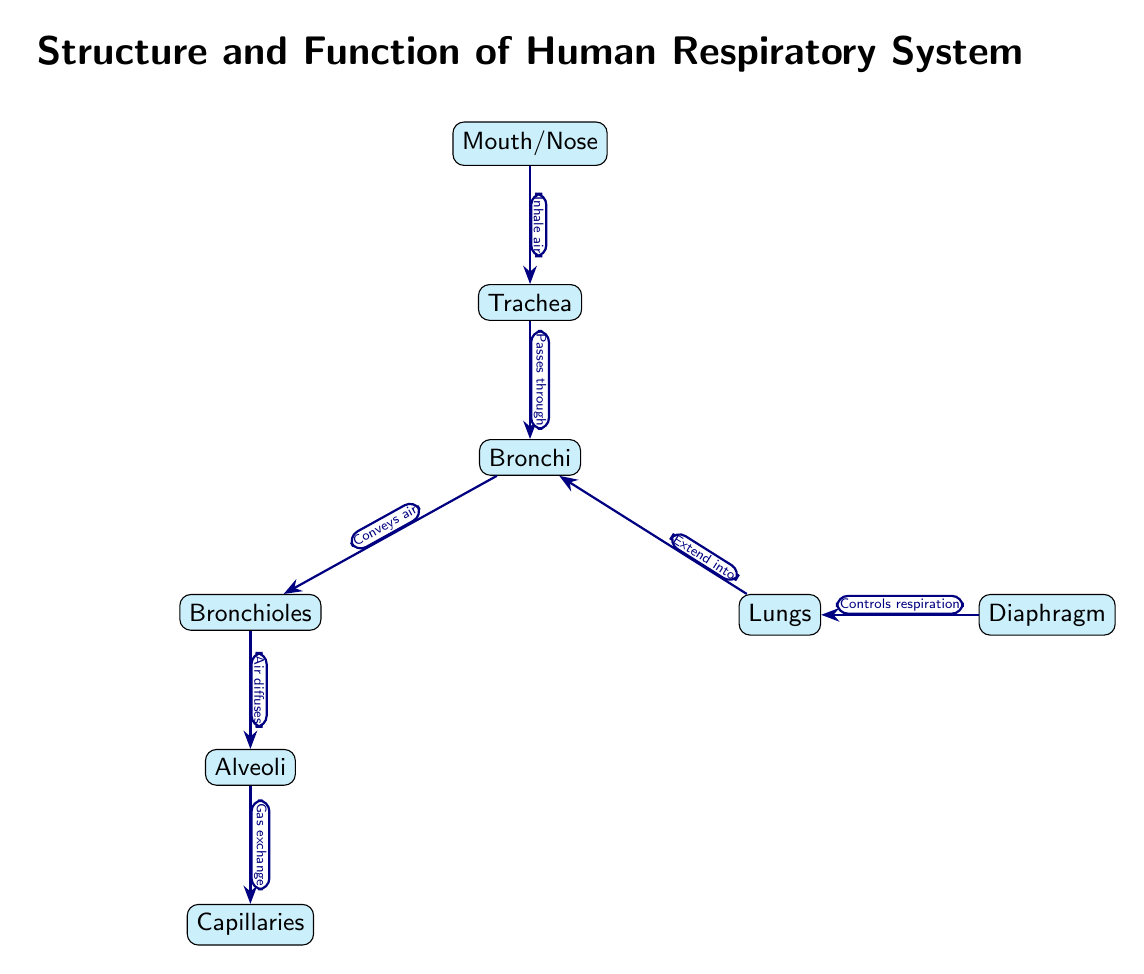What is the first structure involved in the respiratory process? The diagram indicates that the first structure involved in the respiratory process is the Mouth/Nose. This is shown at the top of the diagram as the starting point for the inhaled air.
Answer: Mouth/Nose Which structure does the trachea connect to? According to the diagram, the trachea connects to the Bronchi, as the arrow labeled "Passes through" points from the trachea to the bronchi.
Answer: Bronchi How many major parts are listed in the respiratory system? The diagram lists six major parts: Mouth/Nose, Trachea, Bronchi, Bronchioles, Alveoli, and Capillaries which adds up to six nodes in the respiratory flow.
Answer: Six What is the function of the diaphragm in the diagram? The diagram states that the diaphragm "Controls respiration," indicating its role as a muscle in the respiratory system that aids in breathing.
Answer: Controls respiration What type of exchange occurs at the alveoli? The diagram indicates that at the alveoli, "Gas exchange" occurs, highlighting the crucial function of this structure regarding oxygen and carbon dioxide transfer.
Answer: Gas exchange What does air do after passing through the bronchi? According to the flow of the diagram, after passing through the bronchi, air conveys to the bronchioles, which shows the sequence of airflow in the respiratory system.
Answer: Conveys air Which structures are directly involved in gas exchange? The diagram shows that gas exchange takes place between Alveoli and Capillaries, as it is indicated by the arrow labeled "Gas exchange" connecting these two nodes.
Answer: Alveoli and Capillaries How does air reach the lungs from the bronchi? The diagram describes that air reaches the lungs from the bronchi by extending into the lungs as indicated by the edge labeled with "Extend into."
Answer: Extend into What’s the last structure air passes through before entering the bloodstream? According to the diagram, the last structure air passes through before entering the bloodstream is the Capillaries, as they are connected to the alveoli where gas exchange occurs.
Answer: Capillaries 